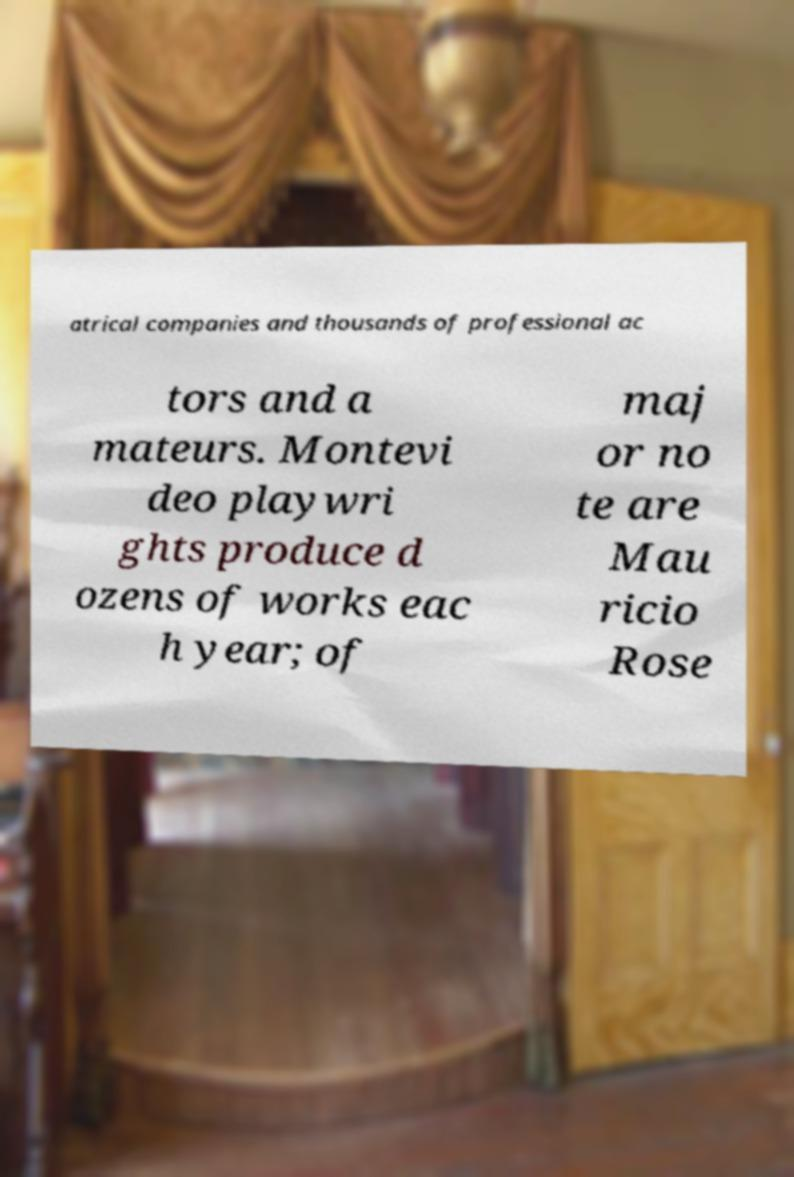For documentation purposes, I need the text within this image transcribed. Could you provide that? atrical companies and thousands of professional ac tors and a mateurs. Montevi deo playwri ghts produce d ozens of works eac h year; of maj or no te are Mau ricio Rose 